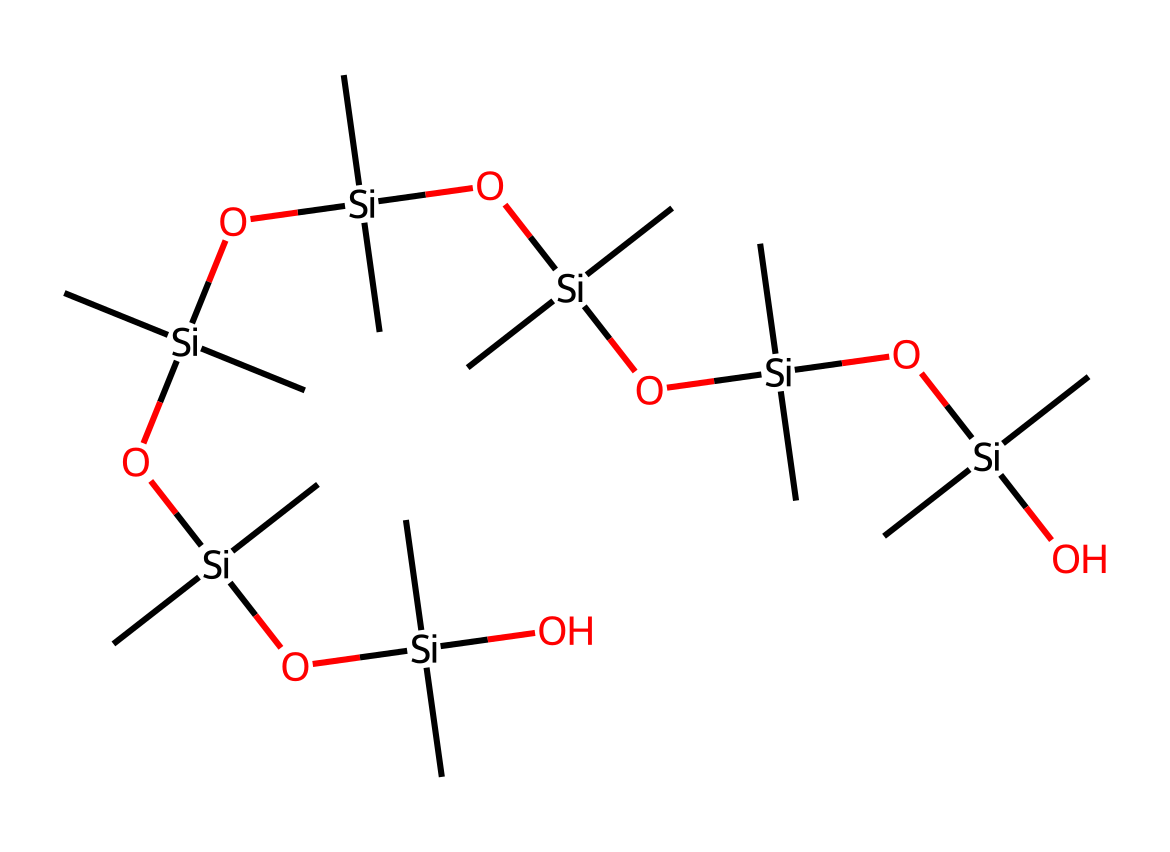What is the main element in this silicone-based lubricant? The structure contains silicon atoms as the primary component throughout the chain, indicating that silicon is the main element.
Answer: silicon How many silicon atoms are present in the structure? By counting the silicon atoms depicted in the SMILES representation, there are 5 silicon atoms in total, which can be identified by the occurrences of "Si".
Answer: 5 What type of chemical bonding is predominant in this silicone structure? The structure primarily features silicon-oxygen bonds, indicated by the repeating Si-O segments throughout.
Answer: Si-O bonds What is the significance of the hydroxyl groups in this lubricant? The hydroxyl (OH) groups are crucial as they contribute to the lubricant's hydrophilicity and ability to form hydrogen bonds, enhancing compatibility with other substances.
Answer: compatibility How does the presence of multiple functional groups affect the lubricant's properties? Multiple functional groups, such as hydroxyl and silicone, enhance properties like thermal stability, lubricity, and resistance to water, which are critical in laboratory settings.
Answer: enhanced properties What would be the expected viscosity of this silicone-based lubricant? Given the structure and typical properties of silicone lubricants, the expected viscosity would be moderate to high, depending on the chain length and branching in the structure.
Answer: moderate to high 